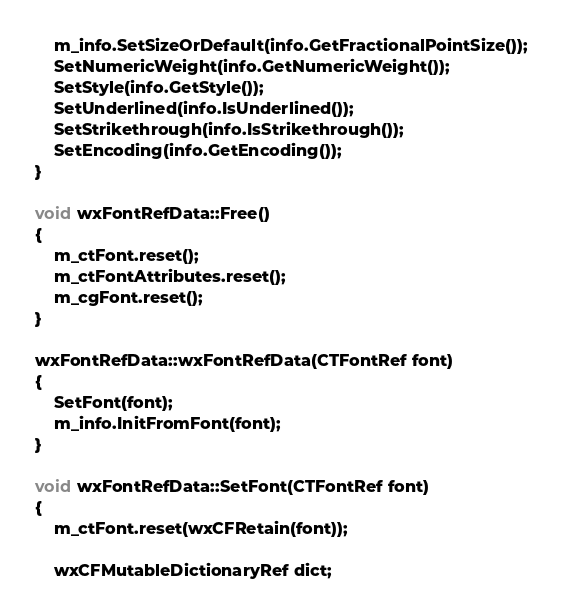<code> <loc_0><loc_0><loc_500><loc_500><_C++_>    m_info.SetSizeOrDefault(info.GetFractionalPointSize());
    SetNumericWeight(info.GetNumericWeight());
    SetStyle(info.GetStyle());
    SetUnderlined(info.IsUnderlined());
    SetStrikethrough(info.IsStrikethrough());
    SetEncoding(info.GetEncoding());
}

void wxFontRefData::Free()
{
    m_ctFont.reset();
    m_ctFontAttributes.reset();
    m_cgFont.reset();
}

wxFontRefData::wxFontRefData(CTFontRef font)
{
    SetFont(font);
    m_info.InitFromFont(font);
}

void wxFontRefData::SetFont(CTFontRef font)
{
    m_ctFont.reset(wxCFRetain(font));

    wxCFMutableDictionaryRef dict;</code> 